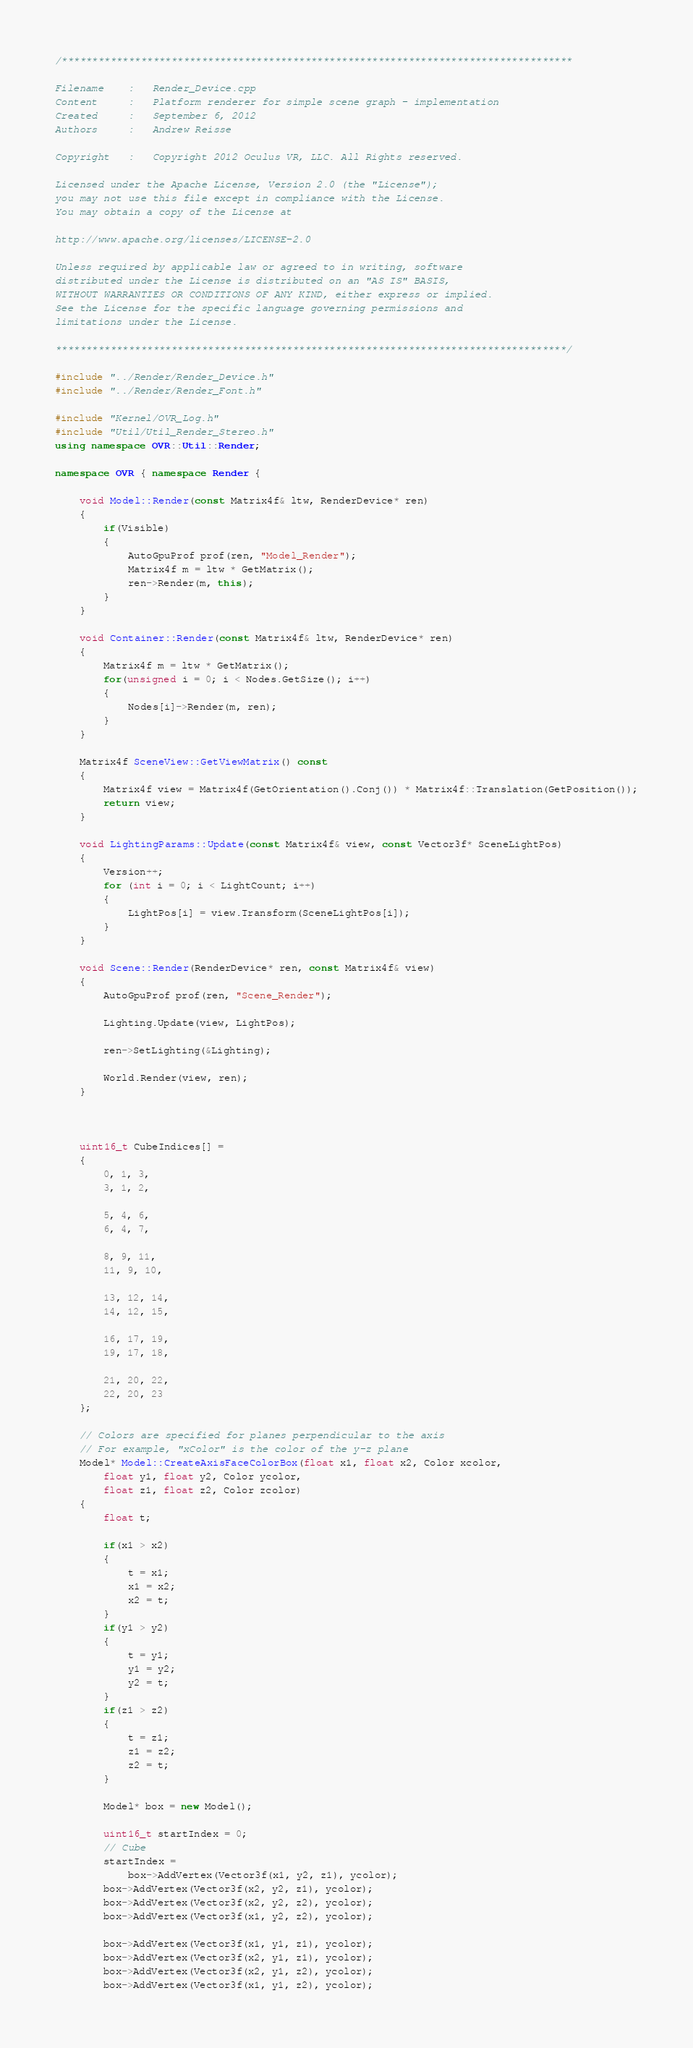Convert code to text. <code><loc_0><loc_0><loc_500><loc_500><_C++_>/************************************************************************************

Filename    :   Render_Device.cpp
Content     :   Platform renderer for simple scene graph - implementation
Created     :   September 6, 2012
Authors     :   Andrew Reisse

Copyright   :   Copyright 2012 Oculus VR, LLC. All Rights reserved.

Licensed under the Apache License, Version 2.0 (the "License");
you may not use this file except in compliance with the License.
You may obtain a copy of the License at

http://www.apache.org/licenses/LICENSE-2.0

Unless required by applicable law or agreed to in writing, software
distributed under the License is distributed on an "AS IS" BASIS,
WITHOUT WARRANTIES OR CONDITIONS OF ANY KIND, either express or implied.
See the License for the specific language governing permissions and
limitations under the License.

************************************************************************************/

#include "../Render/Render_Device.h"
#include "../Render/Render_Font.h"

#include "Kernel/OVR_Log.h"
#include "Util/Util_Render_Stereo.h"
using namespace OVR::Util::Render;

namespace OVR { namespace Render {

	void Model::Render(const Matrix4f& ltw, RenderDevice* ren)
	{
		if(Visible)
		{
			AutoGpuProf prof(ren, "Model_Render");
			Matrix4f m = ltw * GetMatrix();
			ren->Render(m, this);
		}
	}

	void Container::Render(const Matrix4f& ltw, RenderDevice* ren)
	{
		Matrix4f m = ltw * GetMatrix();
		for(unsigned i = 0; i < Nodes.GetSize(); i++)
		{
			Nodes[i]->Render(m, ren);
		}
	}

	Matrix4f SceneView::GetViewMatrix() const
	{
		Matrix4f view = Matrix4f(GetOrientation().Conj()) * Matrix4f::Translation(GetPosition());
		return view;
	}

	void LightingParams::Update(const Matrix4f& view, const Vector3f* SceneLightPos)
	{
		Version++;
		for (int i = 0; i < LightCount; i++)
		{
			LightPos[i] = view.Transform(SceneLightPos[i]);
		}
	}

	void Scene::Render(RenderDevice* ren, const Matrix4f& view)
	{
		AutoGpuProf prof(ren, "Scene_Render");

		Lighting.Update(view, LightPos);

		ren->SetLighting(&Lighting);

		World.Render(view, ren);
	}



	uint16_t CubeIndices[] =
	{
		0, 1, 3,
		3, 1, 2,

		5, 4, 6,
		6, 4, 7,

		8, 9, 11,
		11, 9, 10,

		13, 12, 14,
		14, 12, 15,

		16, 17, 19,
		19, 17, 18,

		21, 20, 22,
		22, 20, 23
	};

	// Colors are specified for planes perpendicular to the axis
	// For example, "xColor" is the color of the y-z plane
	Model* Model::CreateAxisFaceColorBox(float x1, float x2, Color xcolor,
		float y1, float y2, Color ycolor,
		float z1, float z2, Color zcolor)
	{
		float t;

		if(x1 > x2)
		{
			t = x1;
			x1 = x2;
			x2 = t;
		}
		if(y1 > y2)
		{
			t = y1;
			y1 = y2;
			y2 = t;
		}
		if(z1 > z2)
		{
			t = z1;
			z1 = z2;
			z2 = t;
		}

		Model* box = new Model();

		uint16_t startIndex = 0;
		// Cube
		startIndex =
			box->AddVertex(Vector3f(x1, y2, z1), ycolor);
		box->AddVertex(Vector3f(x2, y2, z1), ycolor);
		box->AddVertex(Vector3f(x2, y2, z2), ycolor);
		box->AddVertex(Vector3f(x1, y2, z2), ycolor);

		box->AddVertex(Vector3f(x1, y1, z1), ycolor);
		box->AddVertex(Vector3f(x2, y1, z1), ycolor);
		box->AddVertex(Vector3f(x2, y1, z2), ycolor);
		box->AddVertex(Vector3f(x1, y1, z2), ycolor);
</code> 